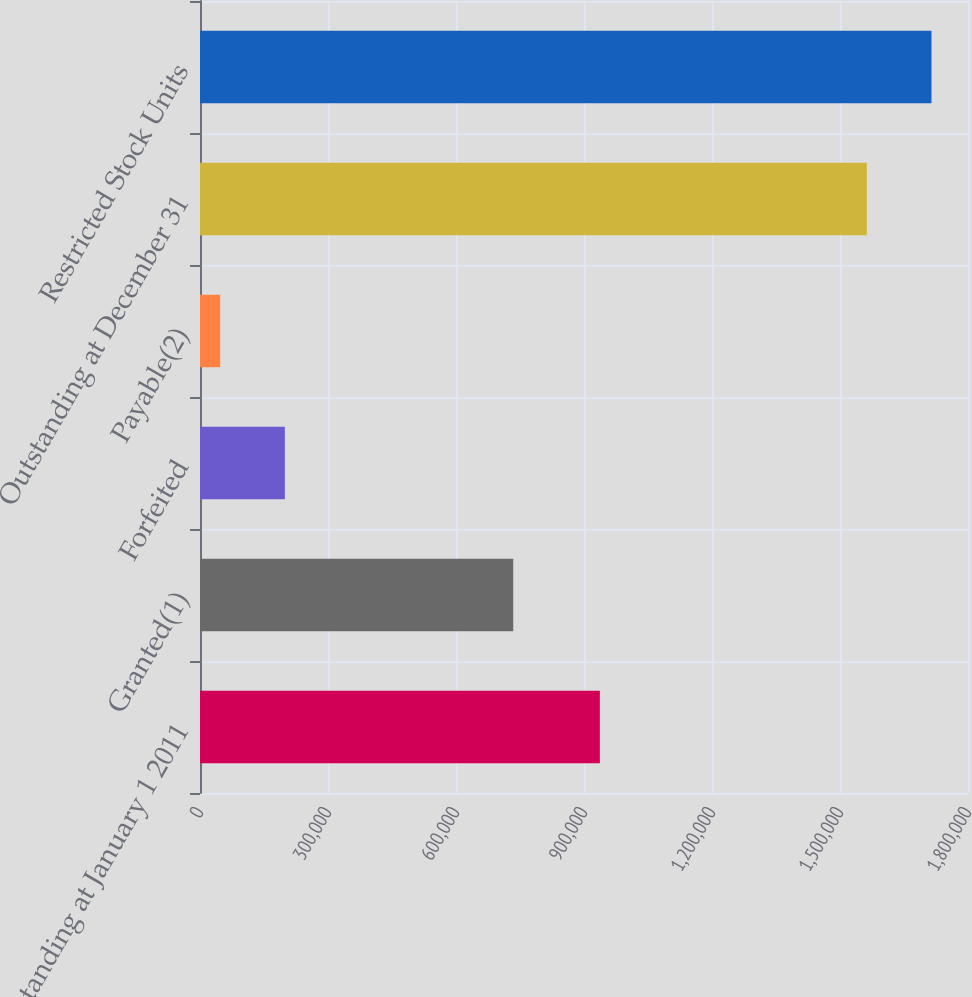<chart> <loc_0><loc_0><loc_500><loc_500><bar_chart><fcel>Outstanding at January 1 2011<fcel>Granted(1)<fcel>Forfeited<fcel>Payable(2)<fcel>Outstanding at December 31<fcel>Restricted Stock Units<nl><fcel>937172<fcel>734159<fcel>198875<fcel>47322<fcel>1.56285e+06<fcel>1.7144e+06<nl></chart> 